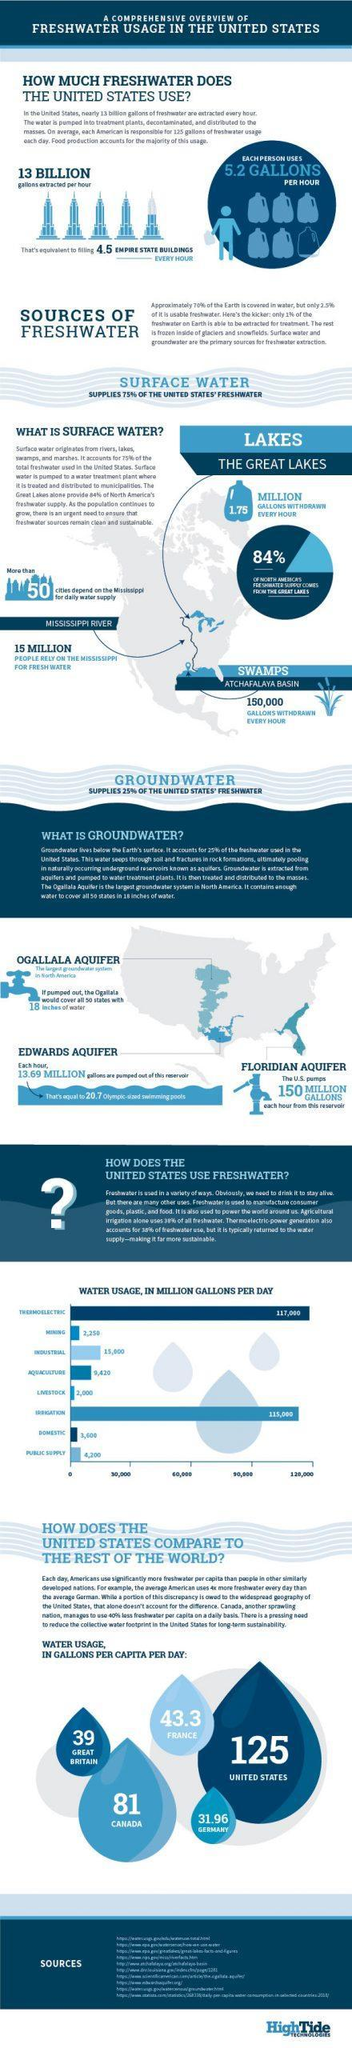How many cities in the USA depends on the Mississippi for daily water supply?
Answer the question with a short phrase. 50 Cities How many Gallons of water are withdrawn from swamps of Atchafalaya Basin every hour? 150,000 Gallons What percentage of North America's fresh water supply comes from The Great Lakes? 84% How many Gallons of fresh water is used by the whole of USA per hour basis? 13 Billion Gallons What constitutes 75% of the United State's fresh water supply? Surface Water How many people rely on Mississippi for fresh water in the USA? 15 Million What constitutes 25% of the United State's fresh water supply? Ground Water How many Gallons of fresh water is used by each person in the USA per hour basis? 5.2 Gallons What constitutes most of the United State's fresh water supply? Surface Water For what purpose is Fresh Water used mostly in the USA on a daily basis? THERMOELECTRIC 